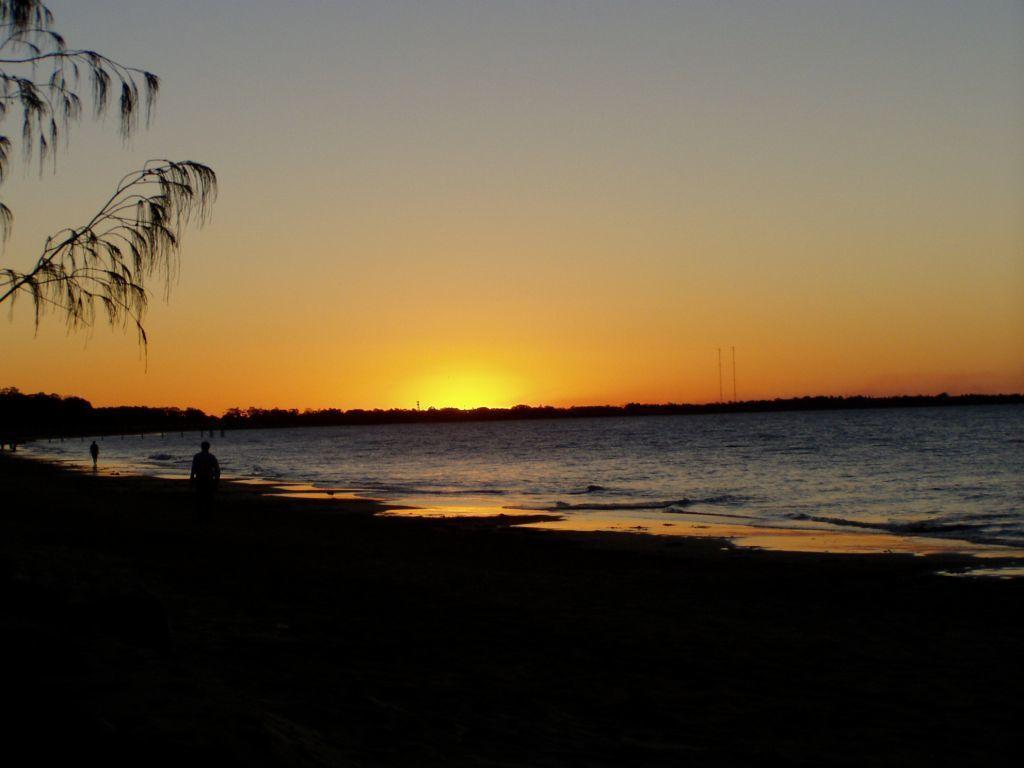In one or two sentences, can you explain what this image depicts? In this image in the front there are persons and in the background there are trees. In the center there is water. 